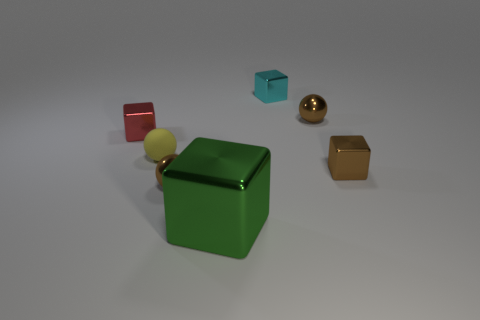Add 2 small brown matte cylinders. How many objects exist? 9 Subtract all yellow spheres. How many spheres are left? 2 Subtract 1 spheres. How many spheres are left? 2 Subtract all cyan blocks. How many blocks are left? 3 Subtract 0 cyan cylinders. How many objects are left? 7 Subtract all cubes. How many objects are left? 3 Subtract all gray balls. Subtract all brown cubes. How many balls are left? 3 Subtract all brown cylinders. How many purple blocks are left? 0 Subtract all tiny yellow objects. Subtract all tiny matte objects. How many objects are left? 5 Add 4 red shiny objects. How many red shiny objects are left? 5 